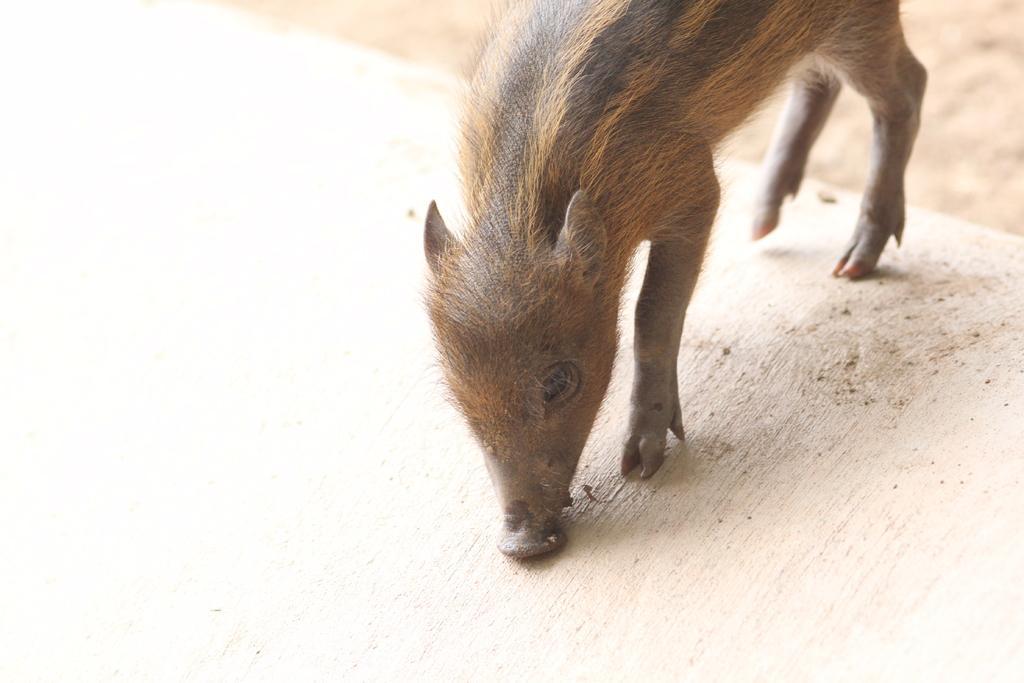Describe this image in one or two sentences. In this image we can see a pig on the ground. 